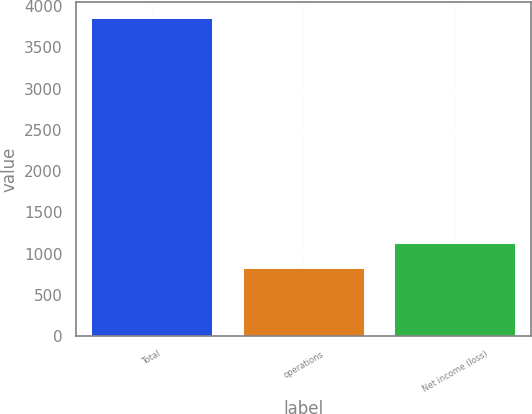<chart> <loc_0><loc_0><loc_500><loc_500><bar_chart><fcel>Total<fcel>operations<fcel>Net income (loss)<nl><fcel>3858<fcel>826<fcel>1129.2<nl></chart> 